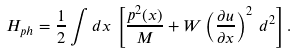<formula> <loc_0><loc_0><loc_500><loc_500>H _ { p h } = \frac { 1 } { 2 } \int d x \, \left [ \frac { p ^ { 2 } ( x ) } { M } + W \left ( \frac { \partial u } { \partial x } \right ) ^ { 2 } \, d ^ { 2 } \right ] .</formula> 